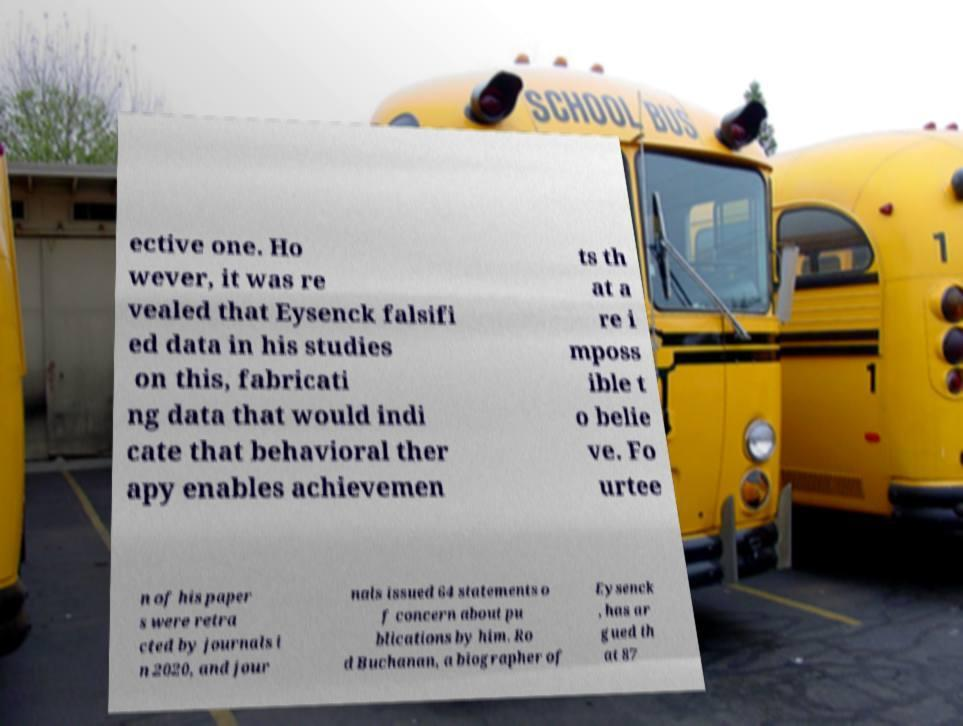Please identify and transcribe the text found in this image. ective one. Ho wever, it was re vealed that Eysenck falsifi ed data in his studies on this, fabricati ng data that would indi cate that behavioral ther apy enables achievemen ts th at a re i mposs ible t o belie ve. Fo urtee n of his paper s were retra cted by journals i n 2020, and jour nals issued 64 statements o f concern about pu blications by him. Ro d Buchanan, a biographer of Eysenck , has ar gued th at 87 